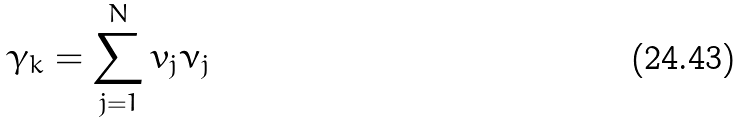Convert formula to latex. <formula><loc_0><loc_0><loc_500><loc_500>\gamma _ { k } = \sum _ { j = 1 } ^ { N } v _ { j } \nu _ { j }</formula> 